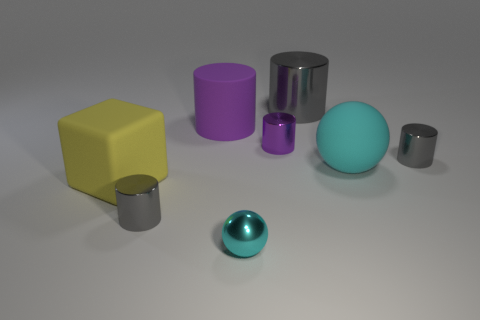Subtract all cyan balls. How many gray cylinders are left? 3 Subtract 2 cylinders. How many cylinders are left? 3 Subtract all purple rubber cylinders. How many cylinders are left? 4 Subtract all cyan cylinders. Subtract all purple cubes. How many cylinders are left? 5 Add 1 small red matte blocks. How many objects exist? 9 Subtract all spheres. How many objects are left? 6 Subtract 0 brown cubes. How many objects are left? 8 Subtract all large purple objects. Subtract all small purple metallic cylinders. How many objects are left? 6 Add 1 yellow blocks. How many yellow blocks are left? 2 Add 2 rubber spheres. How many rubber spheres exist? 3 